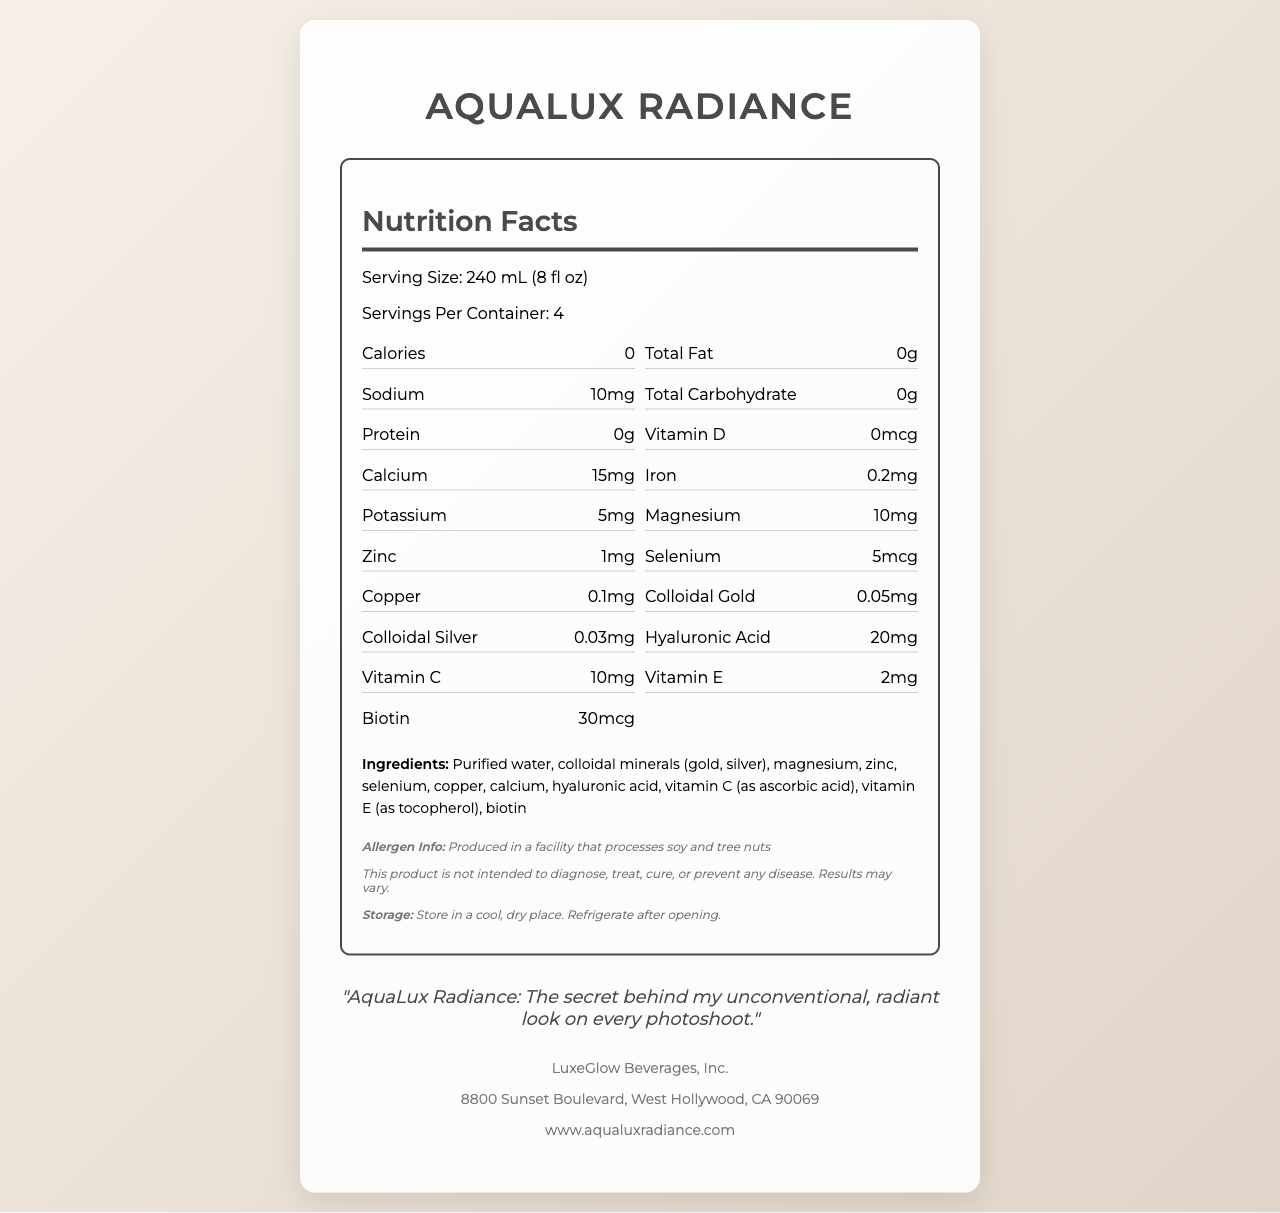What is the serving size of AquaLux Radiance? The serving size is clearly listed under the Nutrition Facts section as 240 mL (8 fl oz).
Answer: 240 mL (8 fl oz) How many servings are there in a container of AquaLux Radiance? The document states that there are 4 servings per container.
Answer: 4 What is the calorie content per serving? The calorie content per serving is indicated as 0 in the Nutrition Facts section.
Answer: 0 What is the amount of vitamin C in AquaLux Radiance? The amount of vitamin C is listed in the Nutrition Facts section as 10mg.
Answer: 10mg How much sodium is there per serving of AquaLux Radiance? The sodium content per serving is indicated as 10mg in the Nutrition Facts section.
Answer: 10mg Which mineral in AquaLux Radiance is present at 1mg per serving? 
A. Zinc 
B. Selenium 
C. Magnesium The Nutrition Facts section shows that zinc is present at 1mg per serving.
Answer: A. Zinc How much hyaluronic acid is in one serving of AquaLux Radiance?
A. 5mg
B. 10mg
C. 15mg
D. 20mg The Nutrition Facts section specifies that there is 20mg of hyaluronic acid per serving.
Answer: D. 20mg Does AquaLux Radiance have any calories? The calorie content is listed as 0 in the Nutrition Facts section, indicating it has no calories.
Answer: No Summarize the main idea of this document. The document provides comprehensive nutritional information about AquaLux Radiance, listing ingredients, serving size, and nutritional content. It emphasizes the skin-enhancing minerals and vitamins, as well as providing storage and allergen information.
Answer: AquaLux Radiance is a luxury, metallic-infused water with various minerals and vitamins including colloidal gold and silver, designed to enhance skin health. Each container has 4 servings, and it includes ingredients like hyaluronic acid, vitamin C, and biotin, with a calorie content of zero. The product is manufactured by LuxeGlow Beverages, Inc. What is the address of the manufacturer of AquaLux Radiance? The manufacturer's address is listed at the end of the document.
Answer: 8800 Sunset Boulevard, West Hollywood, CA 90069 Are there any allergens mentioned in this product? The document notes that the product is produced in a facility that processes soy and tree nuts.
Answer: Yes What type of minerals are infused in AquaLux Radiance? The Ingredients list shows that the water contains colloidal minerals such as gold and silver.
Answer: Colloidal gold and colloidal silver Is AquaLux Radiance intended to diagnose, treat, cure, or prevent any disease? The disclaimer explicitly states that the product is not intended to diagnose, treat, cure, or prevent any disease.
Answer: No Can the exact manufacturing process of AquaLux Radiance be determined from this document? The document does not provide details about the manufacturing process, only general product and nutritional information.
Answer: Not enough information What is the model's statement regarding AquaLux Radiance? The statement is included separately in the document, highlighting the association of the product with the model's radiant look.
Answer: "AquaLux Radiance: The secret behind my unconventional, radiant look on every photoshoot." 